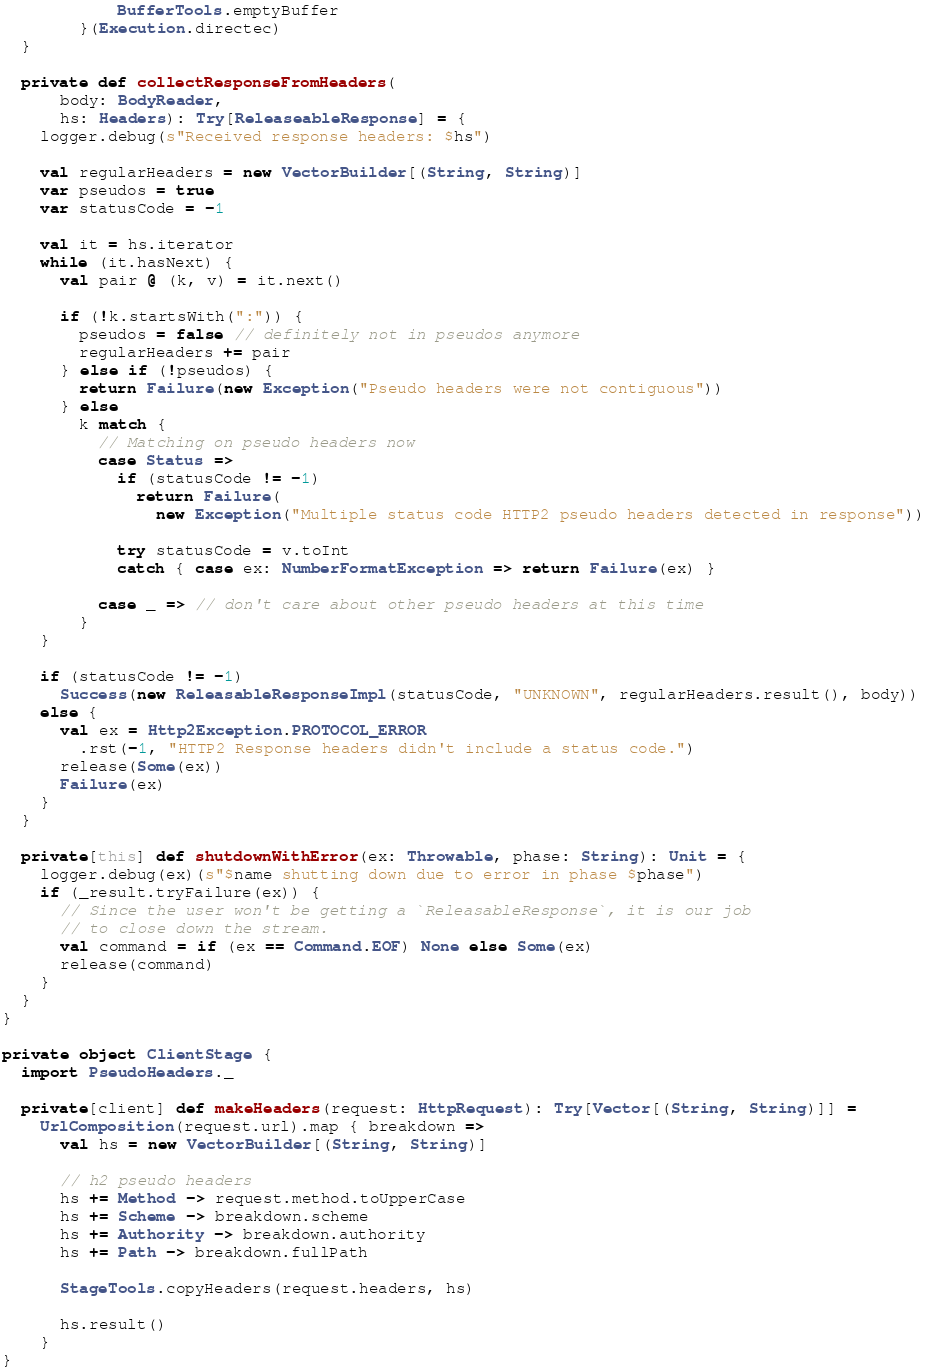<code> <loc_0><loc_0><loc_500><loc_500><_Scala_>            BufferTools.emptyBuffer
        }(Execution.directec)
  }

  private def collectResponseFromHeaders(
      body: BodyReader,
      hs: Headers): Try[ReleaseableResponse] = {
    logger.debug(s"Received response headers: $hs")

    val regularHeaders = new VectorBuilder[(String, String)]
    var pseudos = true
    var statusCode = -1

    val it = hs.iterator
    while (it.hasNext) {
      val pair @ (k, v) = it.next()

      if (!k.startsWith(":")) {
        pseudos = false // definitely not in pseudos anymore
        regularHeaders += pair
      } else if (!pseudos) {
        return Failure(new Exception("Pseudo headers were not contiguous"))
      } else
        k match {
          // Matching on pseudo headers now
          case Status =>
            if (statusCode != -1)
              return Failure(
                new Exception("Multiple status code HTTP2 pseudo headers detected in response"))

            try statusCode = v.toInt
            catch { case ex: NumberFormatException => return Failure(ex) }

          case _ => // don't care about other pseudo headers at this time
        }
    }

    if (statusCode != -1)
      Success(new ReleasableResponseImpl(statusCode, "UNKNOWN", regularHeaders.result(), body))
    else {
      val ex = Http2Exception.PROTOCOL_ERROR
        .rst(-1, "HTTP2 Response headers didn't include a status code.")
      release(Some(ex))
      Failure(ex)
    }
  }

  private[this] def shutdownWithError(ex: Throwable, phase: String): Unit = {
    logger.debug(ex)(s"$name shutting down due to error in phase $phase")
    if (_result.tryFailure(ex)) {
      // Since the user won't be getting a `ReleasableResponse`, it is our job
      // to close down the stream.
      val command = if (ex == Command.EOF) None else Some(ex)
      release(command)
    }
  }
}

private object ClientStage {
  import PseudoHeaders._

  private[client] def makeHeaders(request: HttpRequest): Try[Vector[(String, String)]] =
    UrlComposition(request.url).map { breakdown =>
      val hs = new VectorBuilder[(String, String)]

      // h2 pseudo headers
      hs += Method -> request.method.toUpperCase
      hs += Scheme -> breakdown.scheme
      hs += Authority -> breakdown.authority
      hs += Path -> breakdown.fullPath

      StageTools.copyHeaders(request.headers, hs)

      hs.result()
    }
}
</code> 